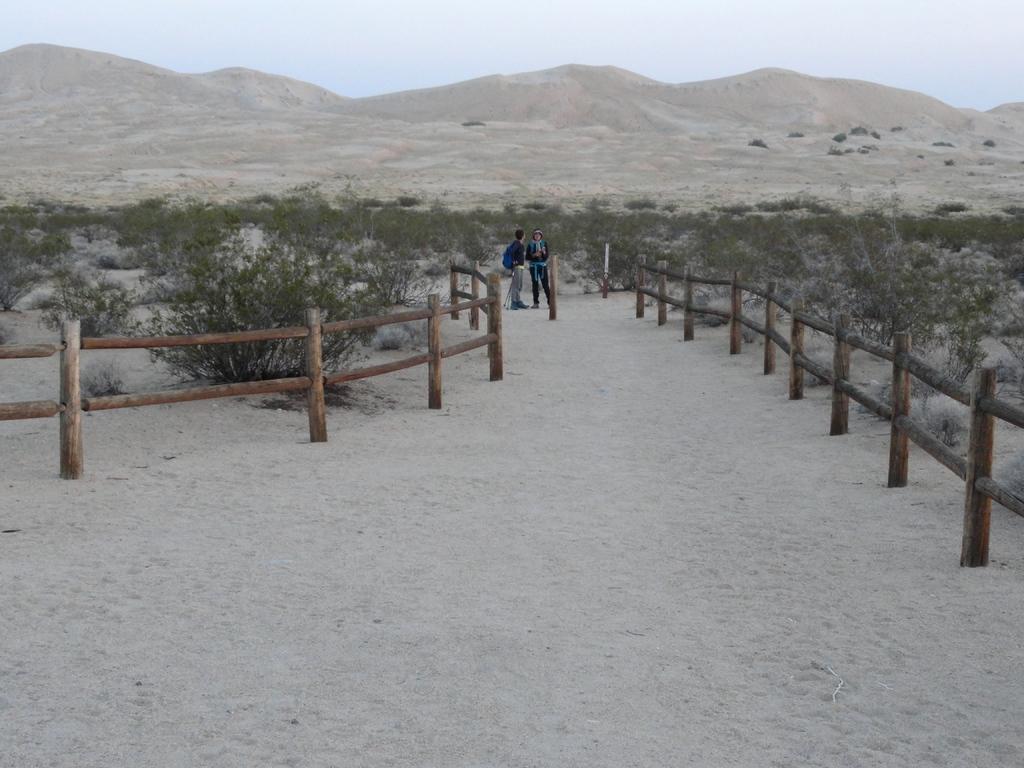Describe this image in one or two sentences. This image is clicked outside. There are bushes in the middle. There are two persons standing in the middle. There are hills at the top. There is sky at the top. 